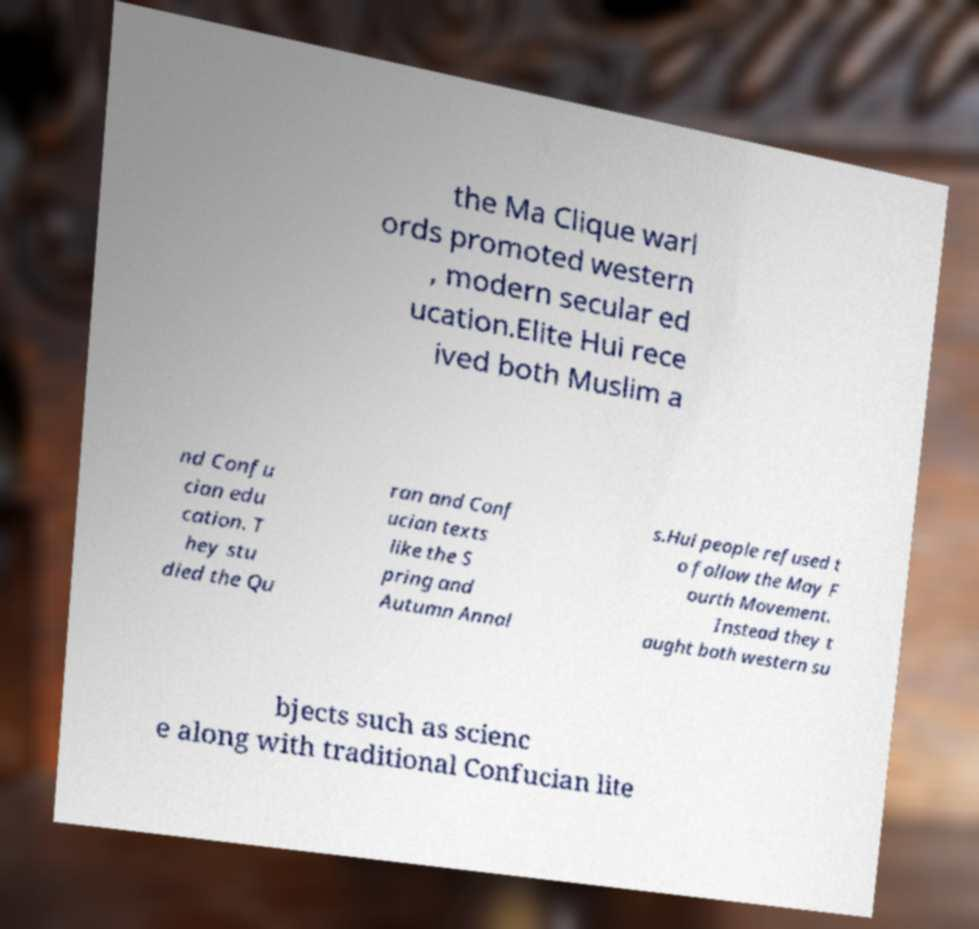What messages or text are displayed in this image? I need them in a readable, typed format. the Ma Clique warl ords promoted western , modern secular ed ucation.Elite Hui rece ived both Muslim a nd Confu cian edu cation. T hey stu died the Qu ran and Conf ucian texts like the S pring and Autumn Annal s.Hui people refused t o follow the May F ourth Movement. Instead they t aught both western su bjects such as scienc e along with traditional Confucian lite 